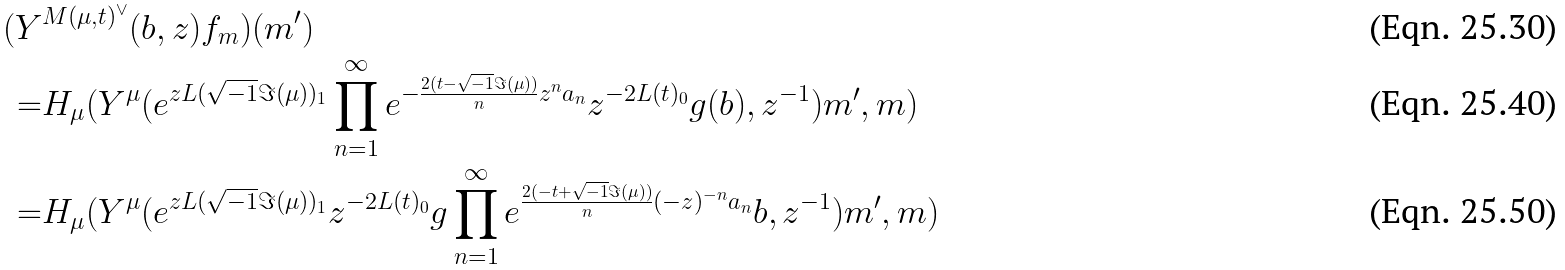Convert formula to latex. <formula><loc_0><loc_0><loc_500><loc_500>( Y & ^ { M ( \mu , t ) ^ { \vee } } ( b , z ) f _ { m } ) ( m ^ { \prime } ) \\ = & H _ { \mu } ( Y ^ { \mu } ( e ^ { z L ( \sqrt { - 1 } \Im ( \mu ) ) _ { 1 } } \prod _ { n = 1 } ^ { \infty } e ^ { - \frac { 2 ( t - \sqrt { - 1 } \Im ( \mu ) ) } { n } z ^ { n } a _ { n } } z ^ { - 2 L ( t ) _ { 0 } } g ( b ) , z ^ { - 1 } ) m ^ { \prime } , m ) \\ = & H _ { \mu } ( Y ^ { \mu } ( e ^ { z L ( \sqrt { - 1 } \Im ( \mu ) ) _ { 1 } } z ^ { - 2 L ( t ) _ { 0 } } g \prod _ { n = 1 } ^ { \infty } e ^ { \frac { 2 ( - t + \sqrt { - 1 } \Im ( \mu ) ) } { n } ( - z ) ^ { - n } a _ { n } } b , z ^ { - 1 } ) m ^ { \prime } , m )</formula> 